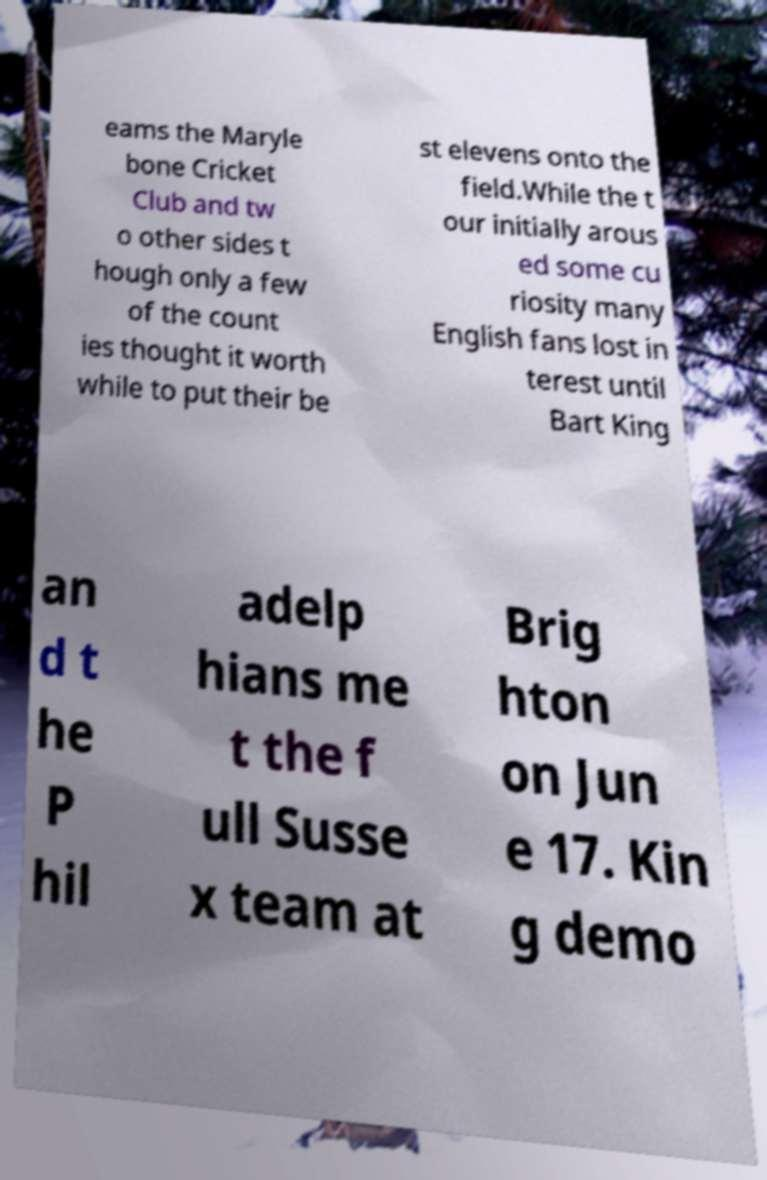There's text embedded in this image that I need extracted. Can you transcribe it verbatim? eams the Maryle bone Cricket Club and tw o other sides t hough only a few of the count ies thought it worth while to put their be st elevens onto the field.While the t our initially arous ed some cu riosity many English fans lost in terest until Bart King an d t he P hil adelp hians me t the f ull Susse x team at Brig hton on Jun e 17. Kin g demo 